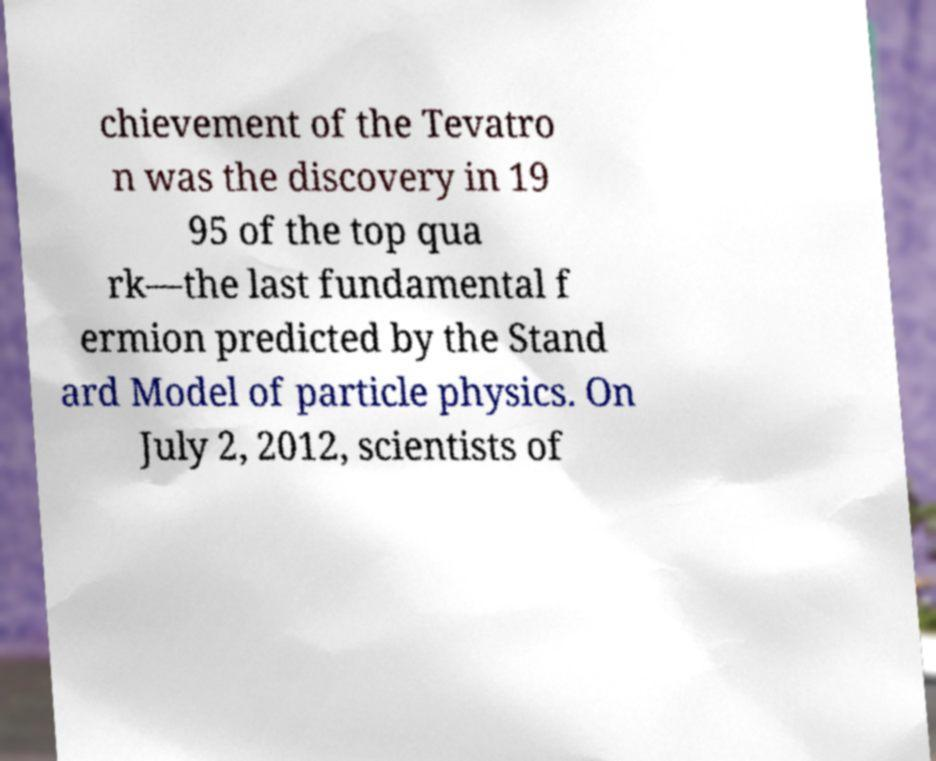For documentation purposes, I need the text within this image transcribed. Could you provide that? chievement of the Tevatro n was the discovery in 19 95 of the top qua rk—the last fundamental f ermion predicted by the Stand ard Model of particle physics. On July 2, 2012, scientists of 